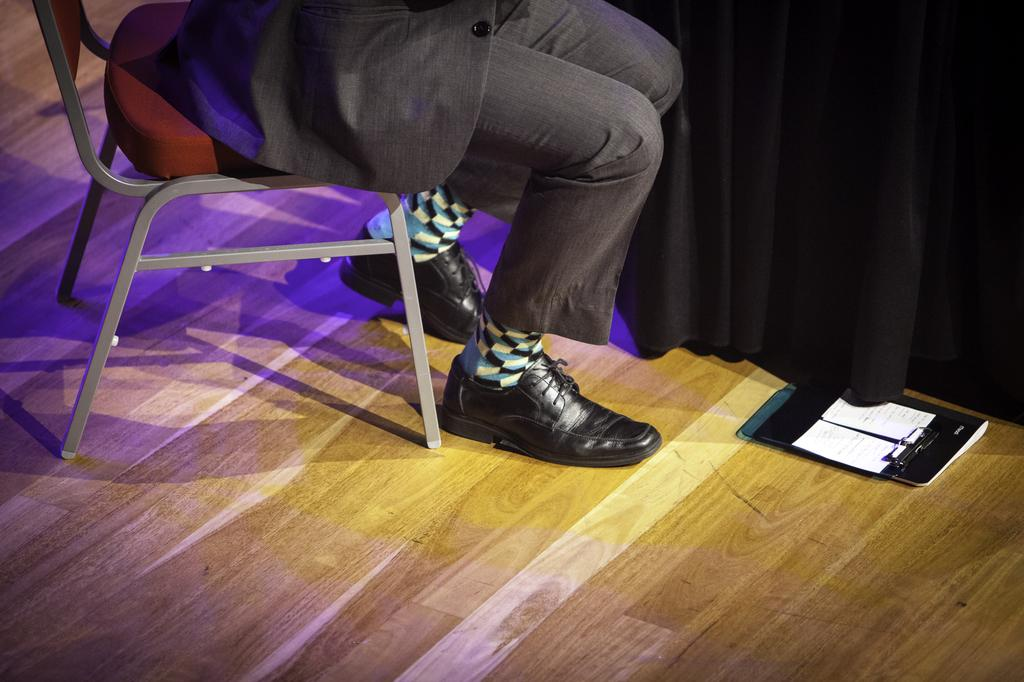What is the person in the image doing? The person is sitting on a chair in the image. What can be seen in the background of the image? There is a curtain in the background of the image. What object is on the floor in the image? There is a book on the floor in the image. How many pears are hanging from the curtain in the image? There are no pears visible in the image; only a curtain can be seen in the background. 